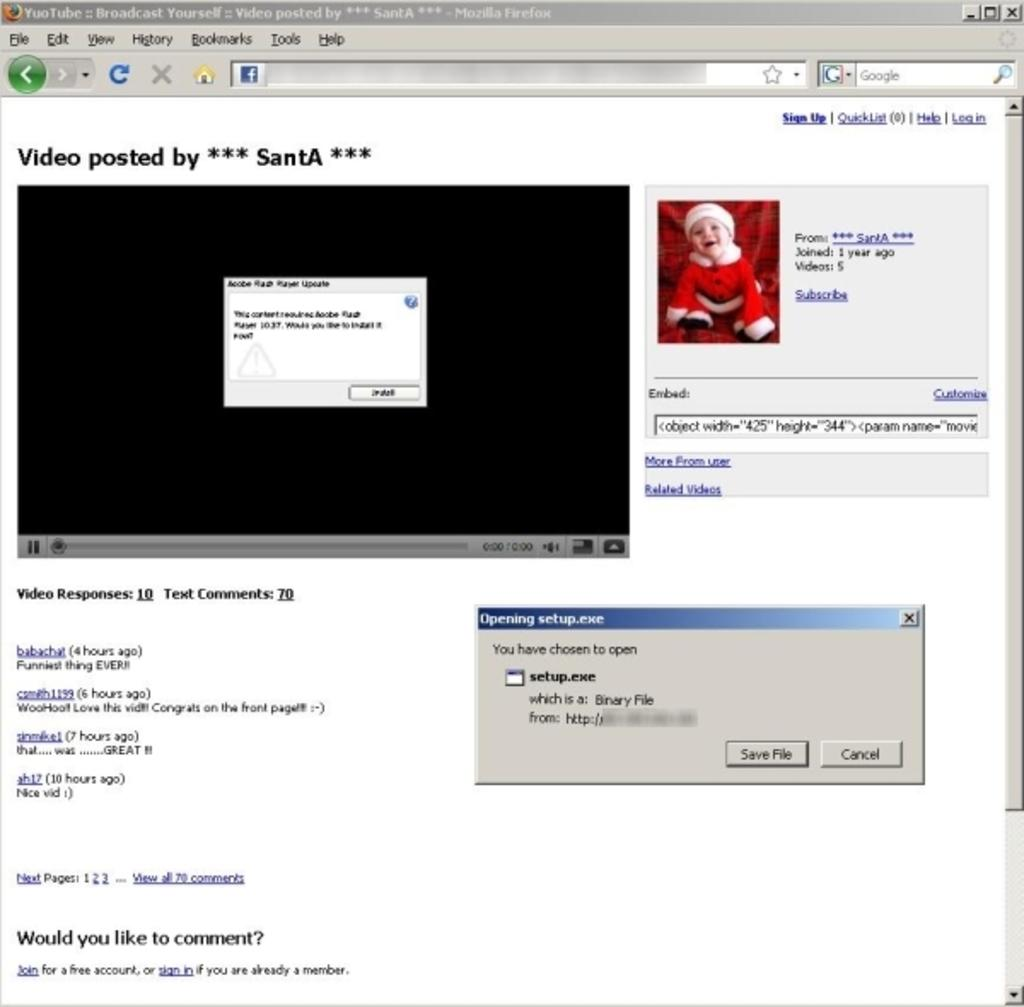Provide a one-sentence caption for the provided image. John posts a Christmas video of his son Tyler on Youtube. 